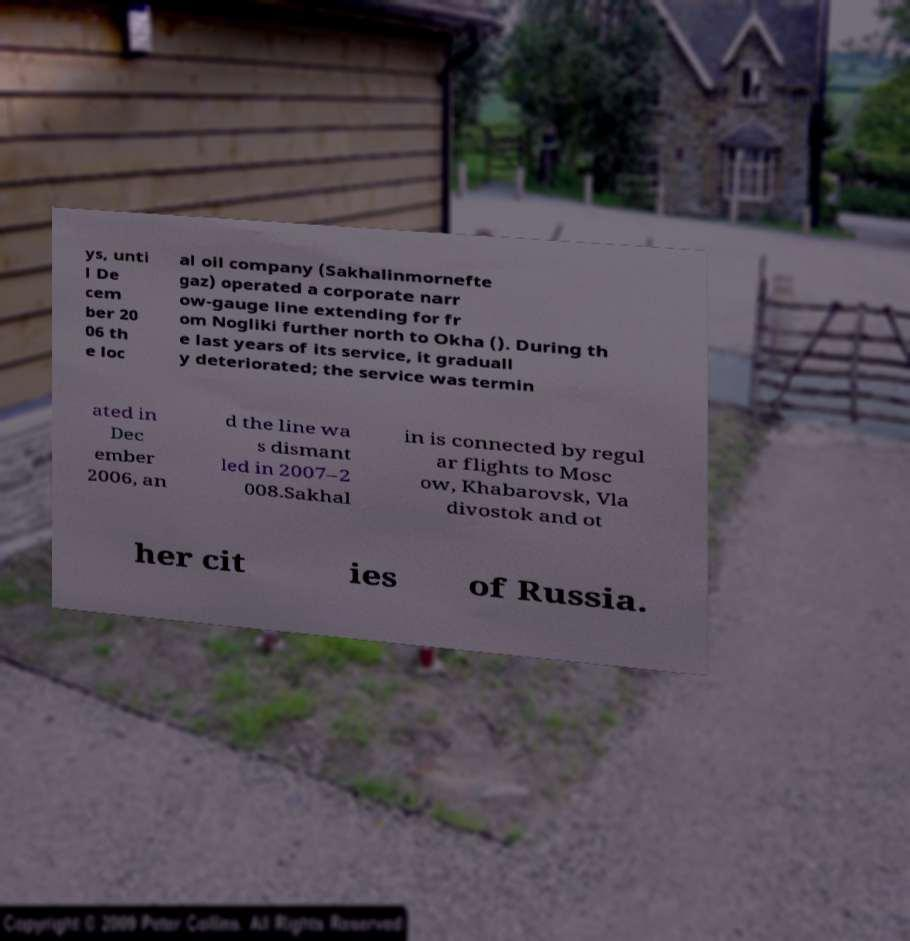Can you accurately transcribe the text from the provided image for me? ys, unti l De cem ber 20 06 th e loc al oil company (Sakhalinmornefte gaz) operated a corporate narr ow-gauge line extending for fr om Nogliki further north to Okha (). During th e last years of its service, it graduall y deteriorated; the service was termin ated in Dec ember 2006, an d the line wa s dismant led in 2007–2 008.Sakhal in is connected by regul ar flights to Mosc ow, Khabarovsk, Vla divostok and ot her cit ies of Russia. 